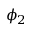Convert formula to latex. <formula><loc_0><loc_0><loc_500><loc_500>\phi _ { 2 }</formula> 